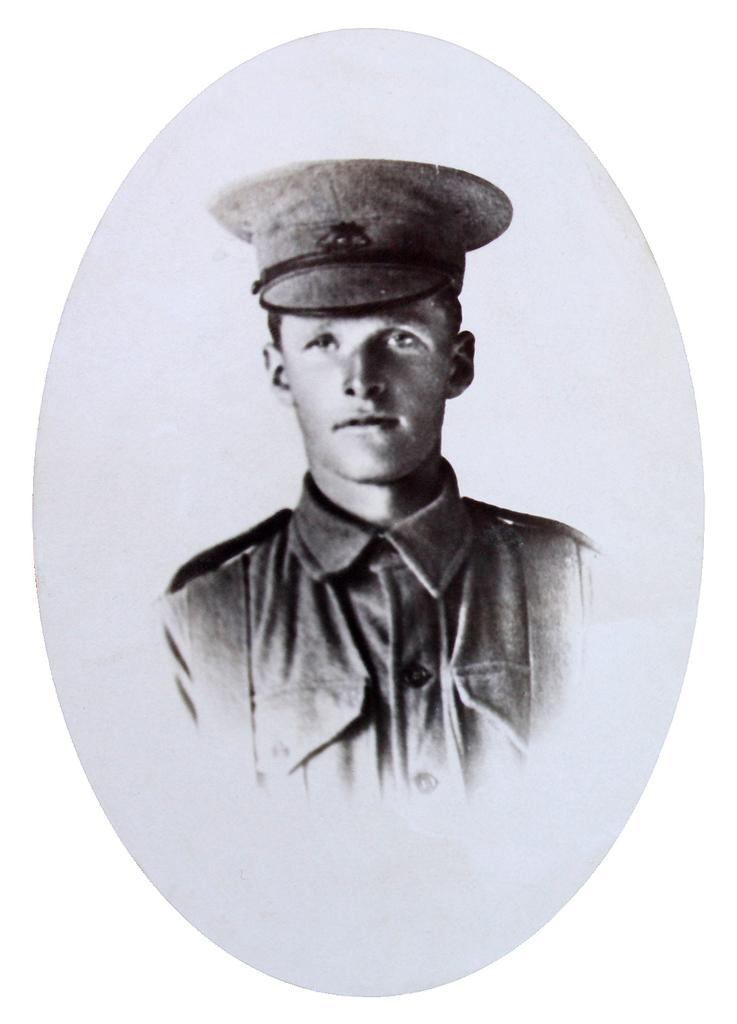What is the main subject of the image? The main subject of the image is a picture of a person. Can you describe the person's attire in the picture? The person in the picture is wearing a cap. How many sheep are visible in the picture? There are no sheep present in the image; it features a picture of a person wearing a cap. What type of lamp is being used by the person in the picture? There is no lamp present in the picture; it only features a person wearing a cap. 